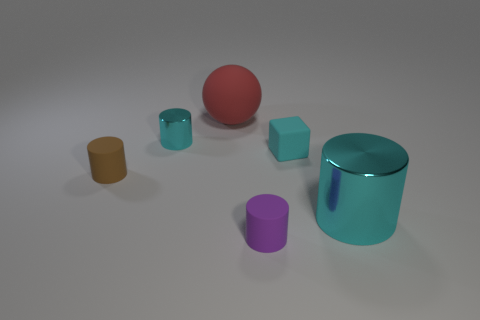Subtract all small metal cylinders. How many cylinders are left? 3 Subtract all spheres. How many objects are left? 5 Subtract 4 cylinders. How many cylinders are left? 0 Add 1 blue blocks. How many objects exist? 7 Subtract all cyan cylinders. How many cylinders are left? 2 Subtract 0 brown cubes. How many objects are left? 6 Subtract all cyan balls. Subtract all brown cylinders. How many balls are left? 1 Subtract all blue blocks. How many purple cylinders are left? 1 Subtract all rubber blocks. Subtract all tiny yellow metallic balls. How many objects are left? 5 Add 2 balls. How many balls are left? 3 